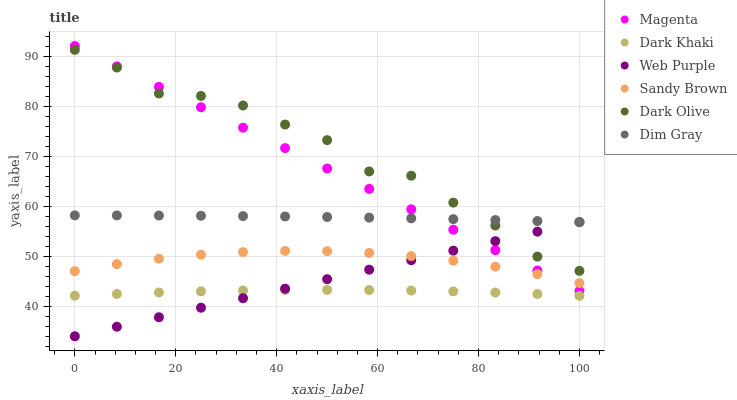Does Dark Khaki have the minimum area under the curve?
Answer yes or no. Yes. Does Dark Olive have the maximum area under the curve?
Answer yes or no. Yes. Does Dark Olive have the minimum area under the curve?
Answer yes or no. No. Does Dark Khaki have the maximum area under the curve?
Answer yes or no. No. Is Web Purple the smoothest?
Answer yes or no. Yes. Is Dark Olive the roughest?
Answer yes or no. Yes. Is Dark Khaki the smoothest?
Answer yes or no. No. Is Dark Khaki the roughest?
Answer yes or no. No. Does Web Purple have the lowest value?
Answer yes or no. Yes. Does Dark Olive have the lowest value?
Answer yes or no. No. Does Magenta have the highest value?
Answer yes or no. Yes. Does Dark Olive have the highest value?
Answer yes or no. No. Is Sandy Brown less than Dark Olive?
Answer yes or no. Yes. Is Dark Olive greater than Dark Khaki?
Answer yes or no. Yes. Does Sandy Brown intersect Magenta?
Answer yes or no. Yes. Is Sandy Brown less than Magenta?
Answer yes or no. No. Is Sandy Brown greater than Magenta?
Answer yes or no. No. Does Sandy Brown intersect Dark Olive?
Answer yes or no. No. 